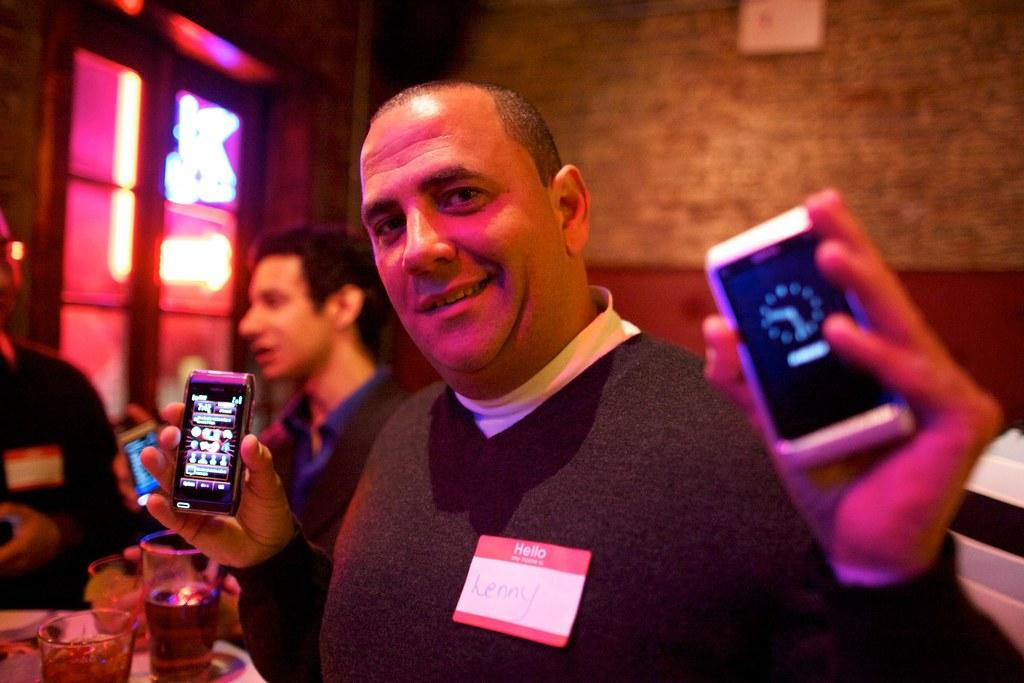<image>
Render a clear and concise summary of the photo. man named Lenny holding a cellphone in each hand 